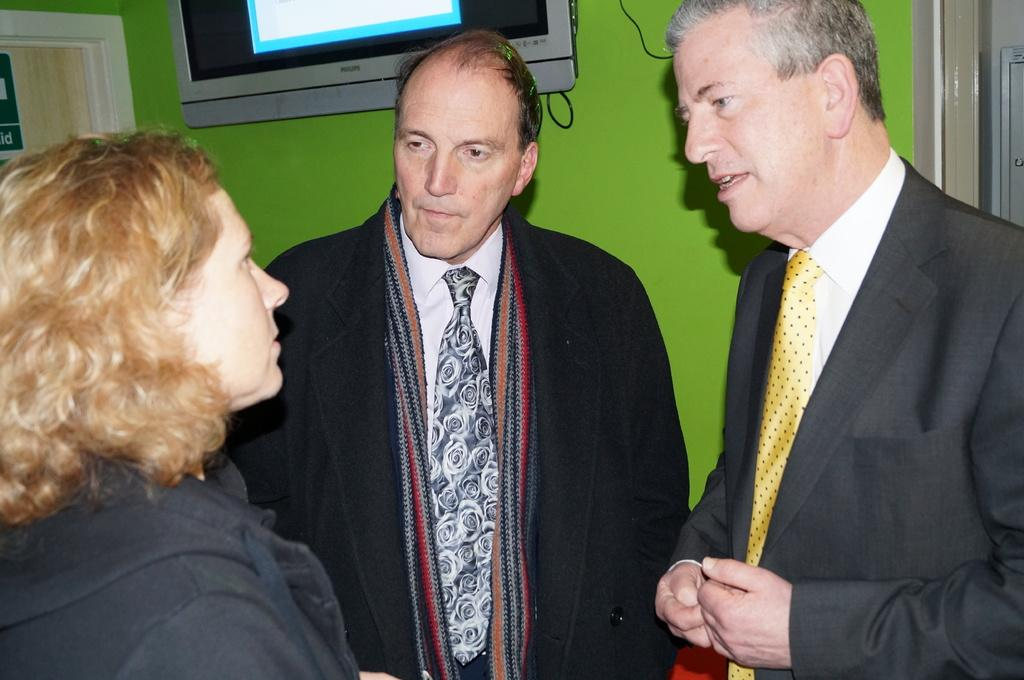How many people are present in the image? There are two men and a woman standing in the image. What can be seen on the backside of the scene? There is a television on the backside of the scene. What architectural feature is visible in the background of the image? There is a door in the background of the image. What type of structure is visible in the background of the image? There is a wall visible in the background of the image. What type of chess pieces are being used by the woman in the image? There is no chessboard or chess pieces visible in the image. What is the woman's interest in the image? The image does not provide information about the woman's interests. 